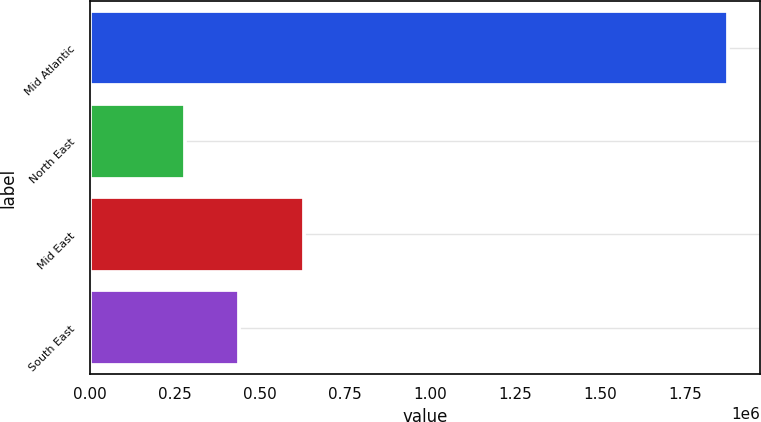Convert chart. <chart><loc_0><loc_0><loc_500><loc_500><bar_chart><fcel>Mid Atlantic<fcel>North East<fcel>Mid East<fcel>South East<nl><fcel>1.8779e+06<fcel>278715<fcel>630367<fcel>438634<nl></chart> 